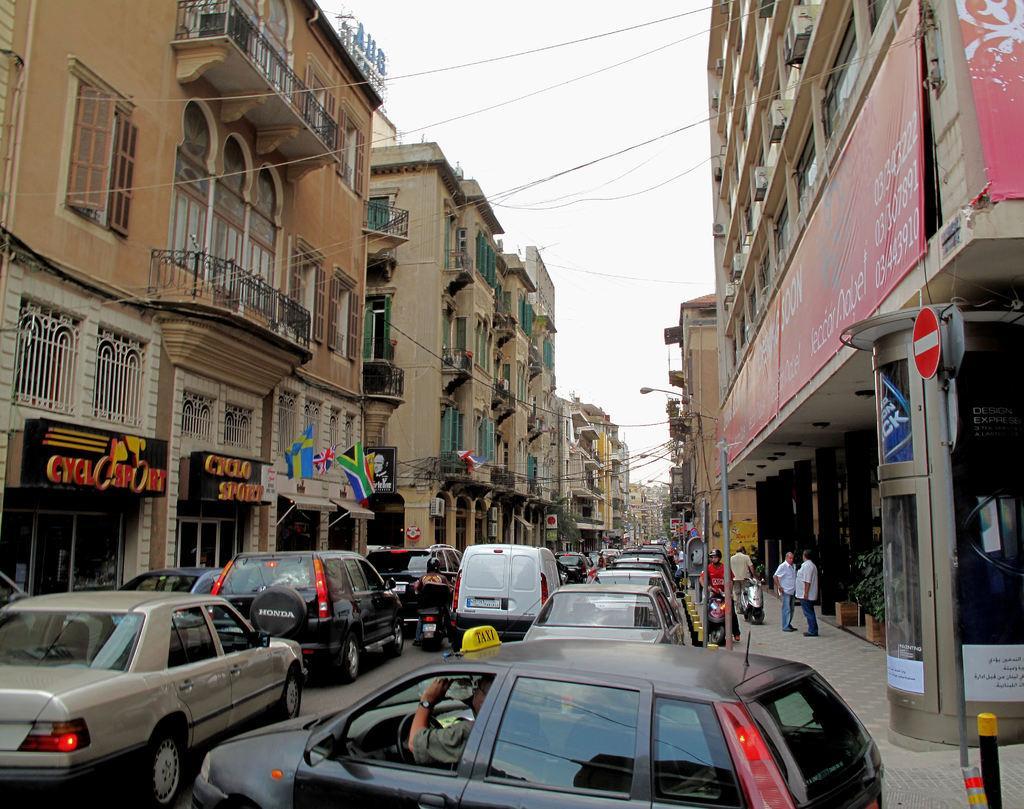Could you give a brief overview of what you see in this image? In this image we can see buildings. In the center of the image there are cars and vehicles on the road. At the top of the image there is sky. There are wires. 